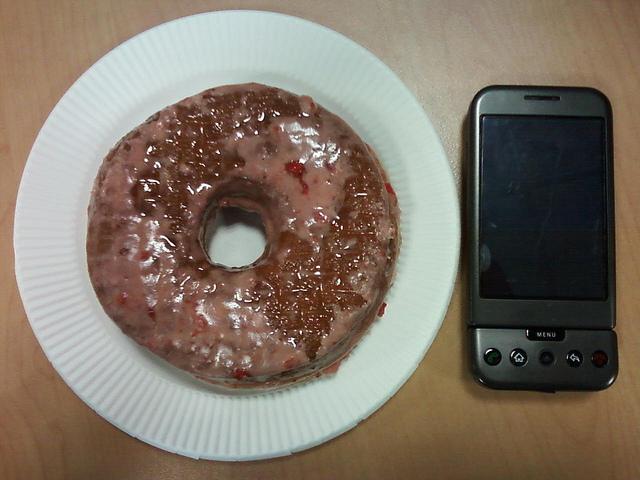Is the plate bigger than the donut?
Be succinct. Yes. How many buttons does the phone have?
Be succinct. 5. What meal does this usually represent?
Quick response, please. Breakfast. 